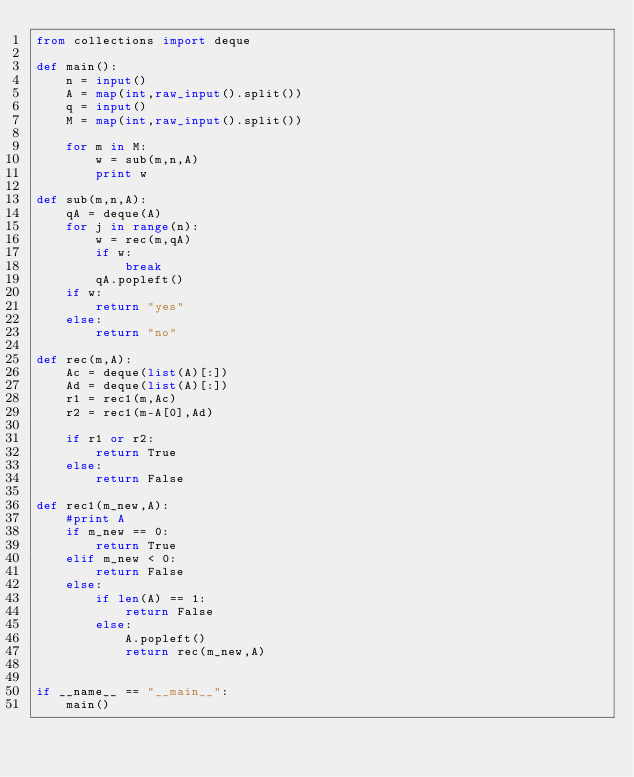<code> <loc_0><loc_0><loc_500><loc_500><_Python_>from collections import deque

def main():
    n = input()
    A = map(int,raw_input().split())
    q = input()
    M = map(int,raw_input().split())

    for m in M:
        w = sub(m,n,A)
        print w
        
def sub(m,n,A):
    qA = deque(A)
    for j in range(n):
        w = rec(m,qA)
        if w:
            break
        qA.popleft()            
    if w:
        return "yes"
    else:
        return "no"
    
def rec(m,A):
    Ac = deque(list(A)[:])
    Ad = deque(list(A)[:])
    r1 = rec1(m,Ac)
    r2 = rec1(m-A[0],Ad)

    if r1 or r2:
        return True
    else:
        return False

def rec1(m_new,A):
    #print A
    if m_new == 0:
        return True
    elif m_new < 0:
        return False
    else:
        if len(A) == 1:
            return False
        else:
            A.popleft()
            return rec(m_new,A)
    

if __name__ == "__main__":
    main()</code> 